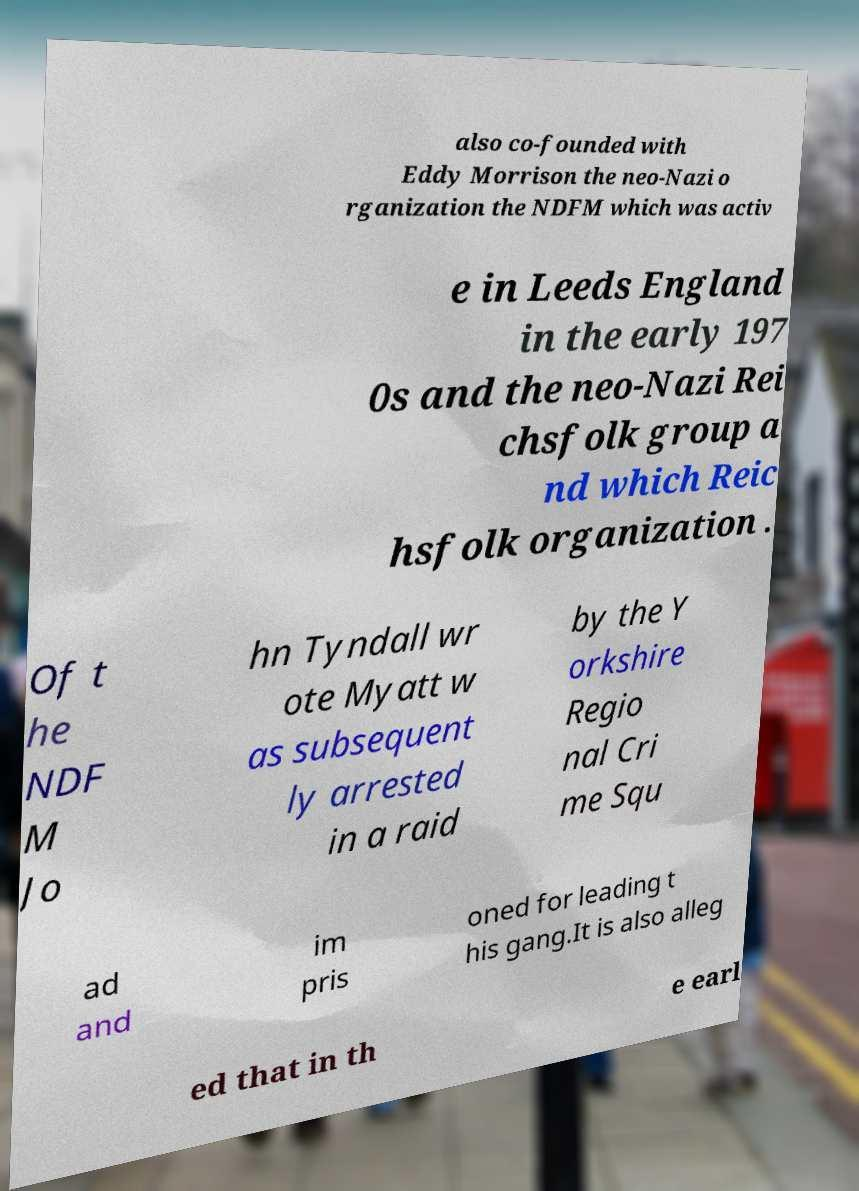Can you read and provide the text displayed in the image?This photo seems to have some interesting text. Can you extract and type it out for me? also co-founded with Eddy Morrison the neo-Nazi o rganization the NDFM which was activ e in Leeds England in the early 197 0s and the neo-Nazi Rei chsfolk group a nd which Reic hsfolk organization . Of t he NDF M Jo hn Tyndall wr ote Myatt w as subsequent ly arrested in a raid by the Y orkshire Regio nal Cri me Squ ad and im pris oned for leading t his gang.It is also alleg ed that in th e earl 